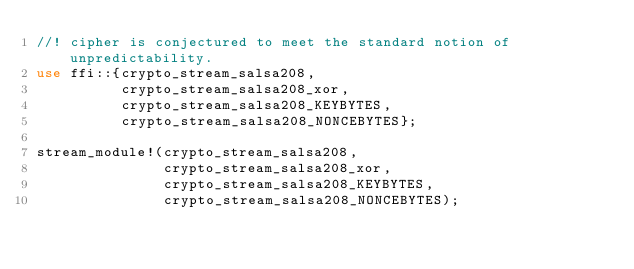Convert code to text. <code><loc_0><loc_0><loc_500><loc_500><_Rust_>//! cipher is conjectured to meet the standard notion of unpredictability.
use ffi::{crypto_stream_salsa208,
          crypto_stream_salsa208_xor,
          crypto_stream_salsa208_KEYBYTES,
          crypto_stream_salsa208_NONCEBYTES};

stream_module!(crypto_stream_salsa208,
               crypto_stream_salsa208_xor,
               crypto_stream_salsa208_KEYBYTES,
               crypto_stream_salsa208_NONCEBYTES);
</code> 